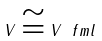<formula> <loc_0><loc_0><loc_500><loc_500>\ V \cong V \ f m l</formula> 